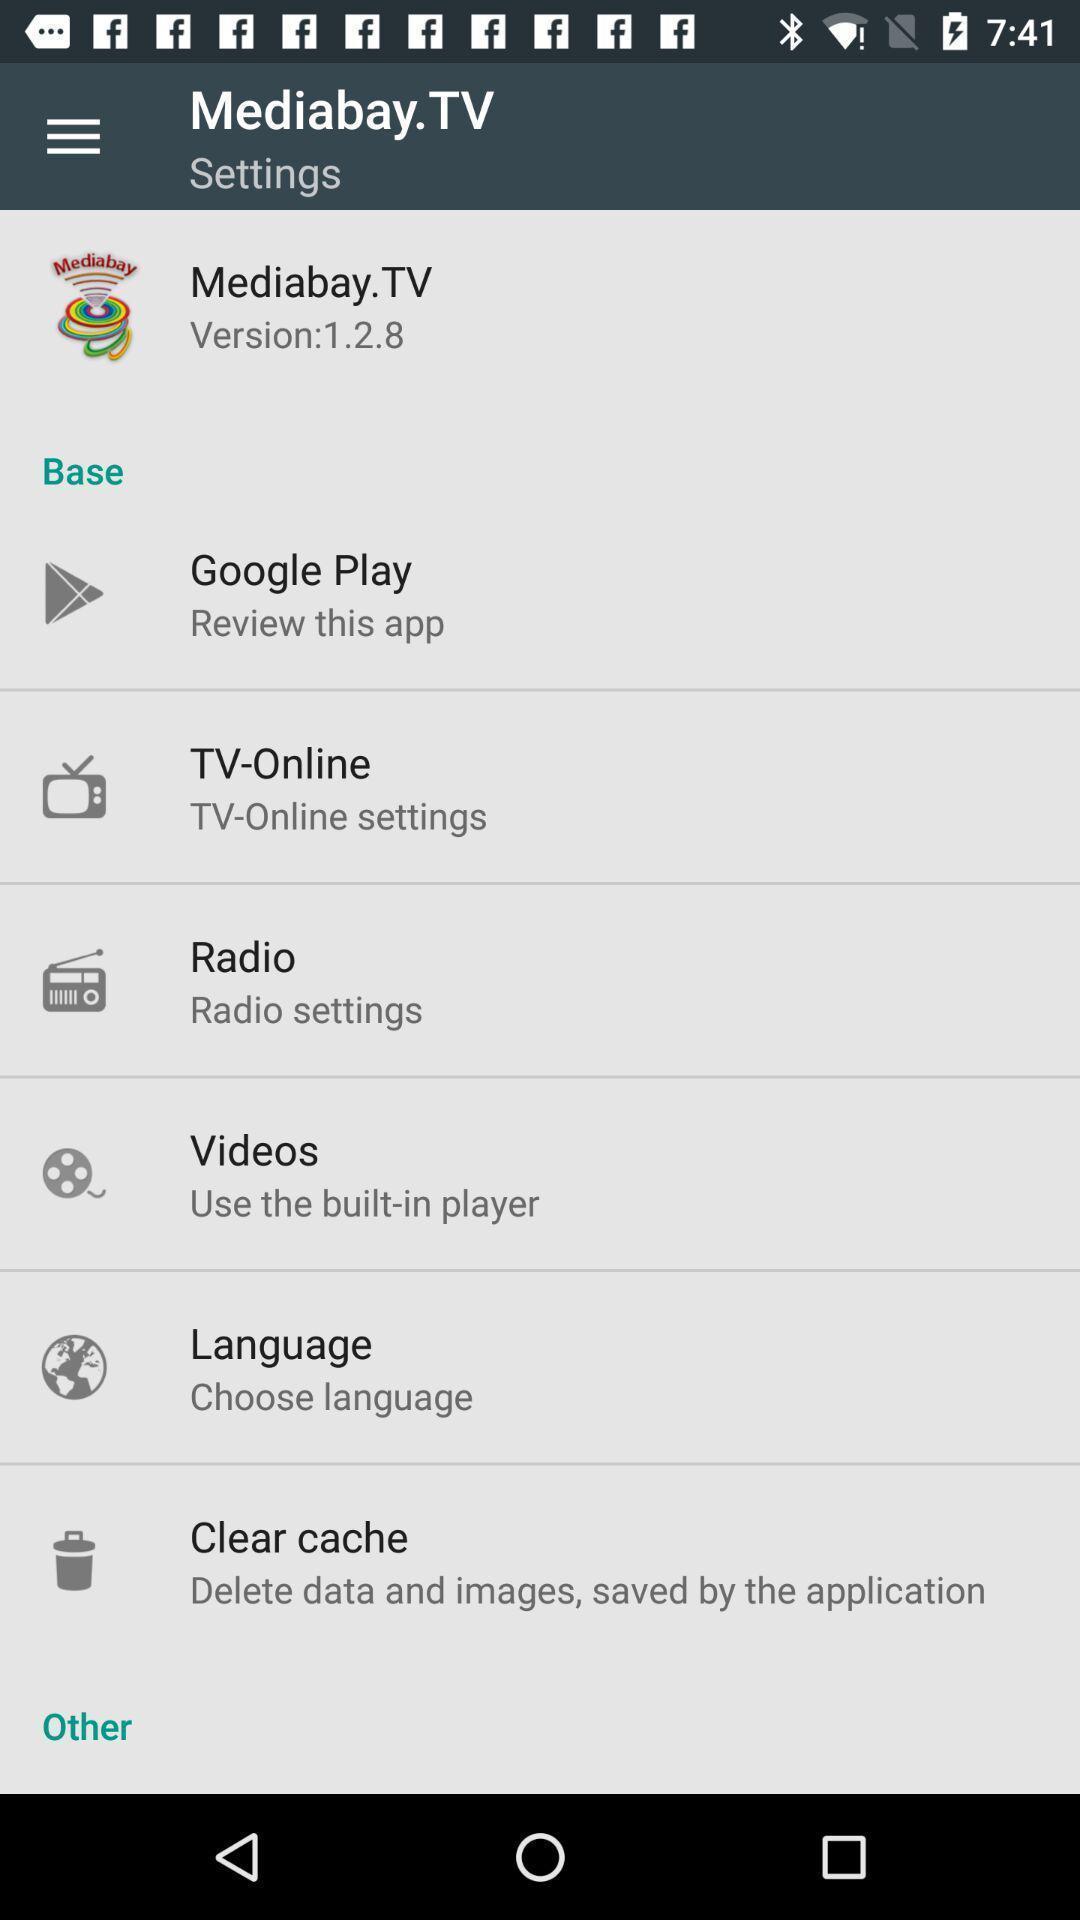What can you discern from this picture? Settings menu for a tv streaming app. 